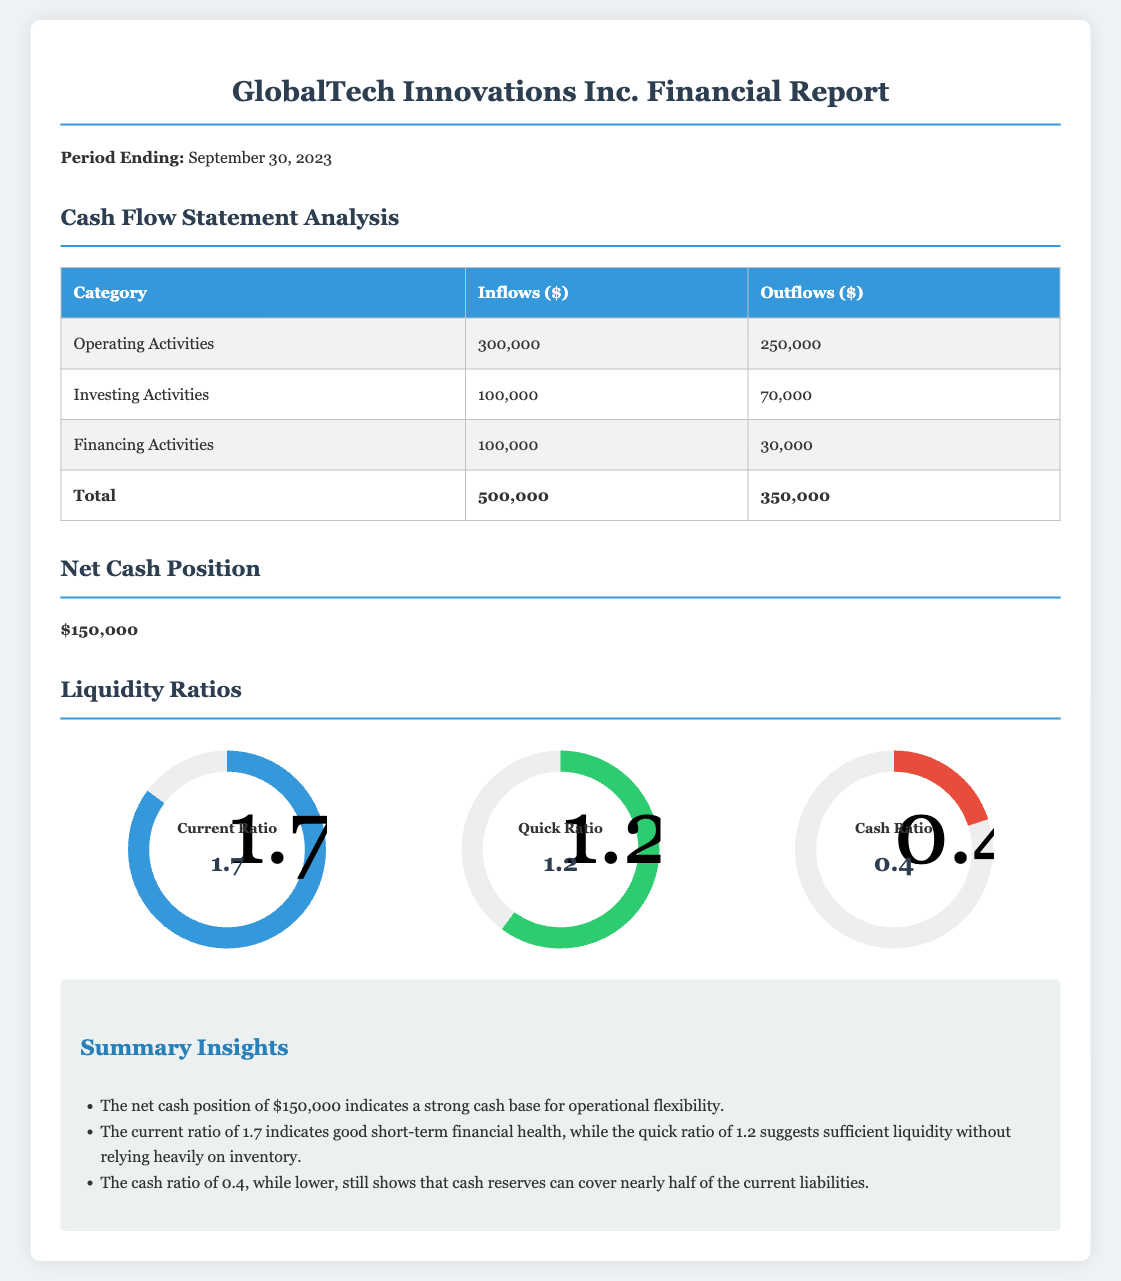What is the period ending date of the report? The report specifies the period ending date as September 30, 2023.
Answer: September 30, 2023 What is the total cash inflow from Operating Activities? The cash inflow from Operating Activities is detailed in the table as $300,000.
Answer: $300,000 What is the total cash outflow for Investing Activities? The cash outflow for Investing Activities is indicated in the table as $70,000.
Answer: $70,000 What is the net cash position reported? The net cash position is explicitly stated in the document as $150,000.
Answer: $150,000 What is the current ratio? The current ratio is shown in the chart as 1.7, indicating the company’s ability to cover short-term liabilities.
Answer: 1.7 How much did the company have in total cash outflows? The document provides a total cash outflow amount of $350,000 as seen in the summary table.
Answer: $350,000 What is the quick ratio according to the report? The quick ratio is illustrated in the chart with a value of 1.2, which reflects liquidity without relying heavily on inventory.
Answer: 1.2 What does the cash ratio value indicate? The cash ratio value of 0.4 is included in the report and it shows that cash reserves can cover nearly half of the current liabilities.
Answer: 0.4 What is the total cash inflow across all activities? The total cash inflow of $500,000 is calculated as the sum of inflows from Operating, Investing, and Financing Activities.
Answer: $500,000 What does the summary suggest about the company's cash base? The summary states that the net cash position indicates a strong cash base for operational flexibility.
Answer: Strong cash base 